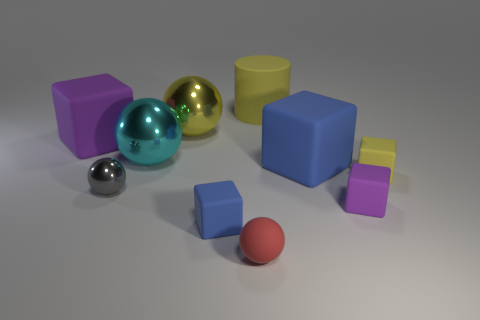What number of other objects are the same material as the large blue object?
Offer a very short reply. 6. What number of metal objects are blue cylinders or large cylinders?
Provide a short and direct response. 0. Is the number of small yellow matte cubes less than the number of big green spheres?
Provide a short and direct response. No. Do the rubber cylinder and the purple block that is in front of the cyan metal ball have the same size?
Offer a terse response. No. Is there anything else that has the same shape as the large yellow matte object?
Provide a succinct answer. No. How big is the yellow sphere?
Your answer should be very brief. Large. Is the number of blue matte cubes that are to the left of the tiny red rubber ball less than the number of purple rubber things?
Provide a succinct answer. Yes. Do the red object and the cyan shiny sphere have the same size?
Make the answer very short. No. What is the color of the large object that is the same material as the yellow ball?
Your answer should be compact. Cyan. Are there fewer yellow metal balls left of the yellow shiny ball than spheres that are behind the large cyan metal ball?
Your answer should be compact. Yes. 